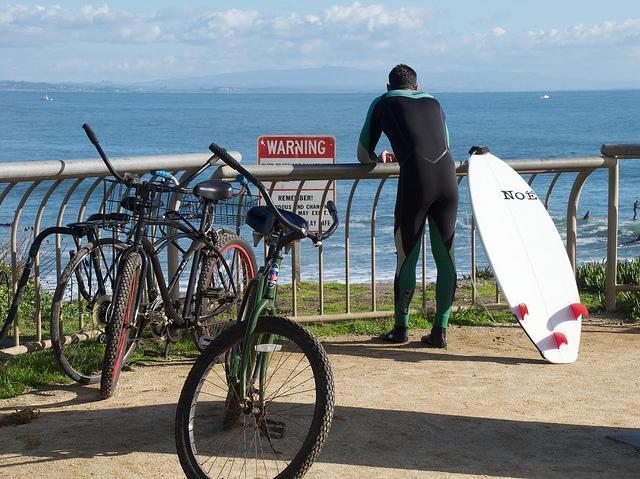How many bicycles are there?
Give a very brief answer. 3. 